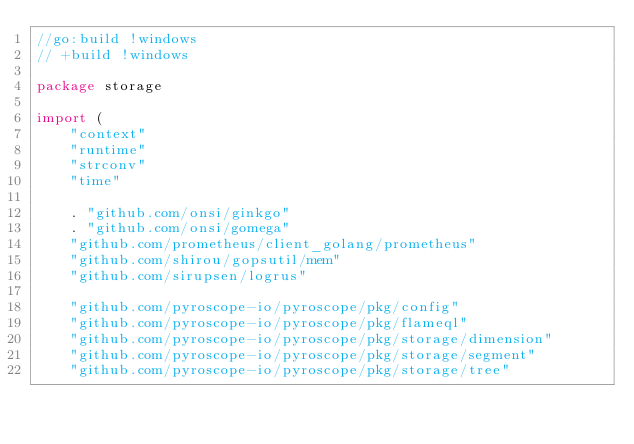<code> <loc_0><loc_0><loc_500><loc_500><_Go_>//go:build !windows
// +build !windows

package storage

import (
	"context"
	"runtime"
	"strconv"
	"time"

	. "github.com/onsi/ginkgo"
	. "github.com/onsi/gomega"
	"github.com/prometheus/client_golang/prometheus"
	"github.com/shirou/gopsutil/mem"
	"github.com/sirupsen/logrus"

	"github.com/pyroscope-io/pyroscope/pkg/config"
	"github.com/pyroscope-io/pyroscope/pkg/flameql"
	"github.com/pyroscope-io/pyroscope/pkg/storage/dimension"
	"github.com/pyroscope-io/pyroscope/pkg/storage/segment"
	"github.com/pyroscope-io/pyroscope/pkg/storage/tree"</code> 